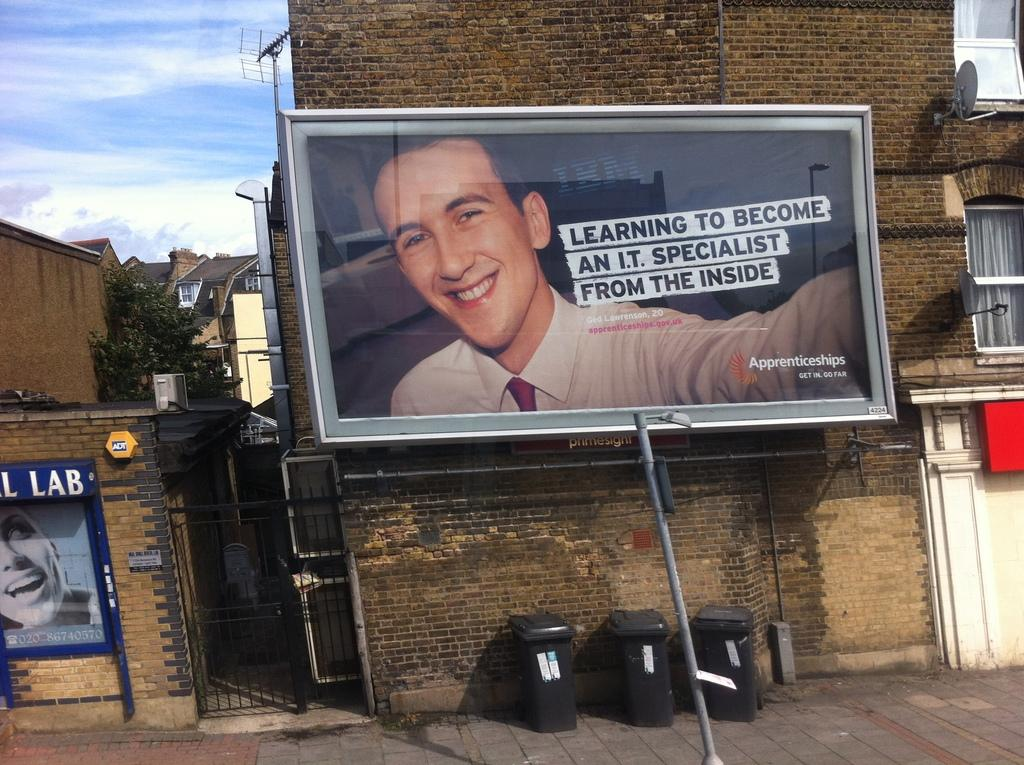<image>
Provide a brief description of the given image. A billboard advertising how to become an i.t. specialist 